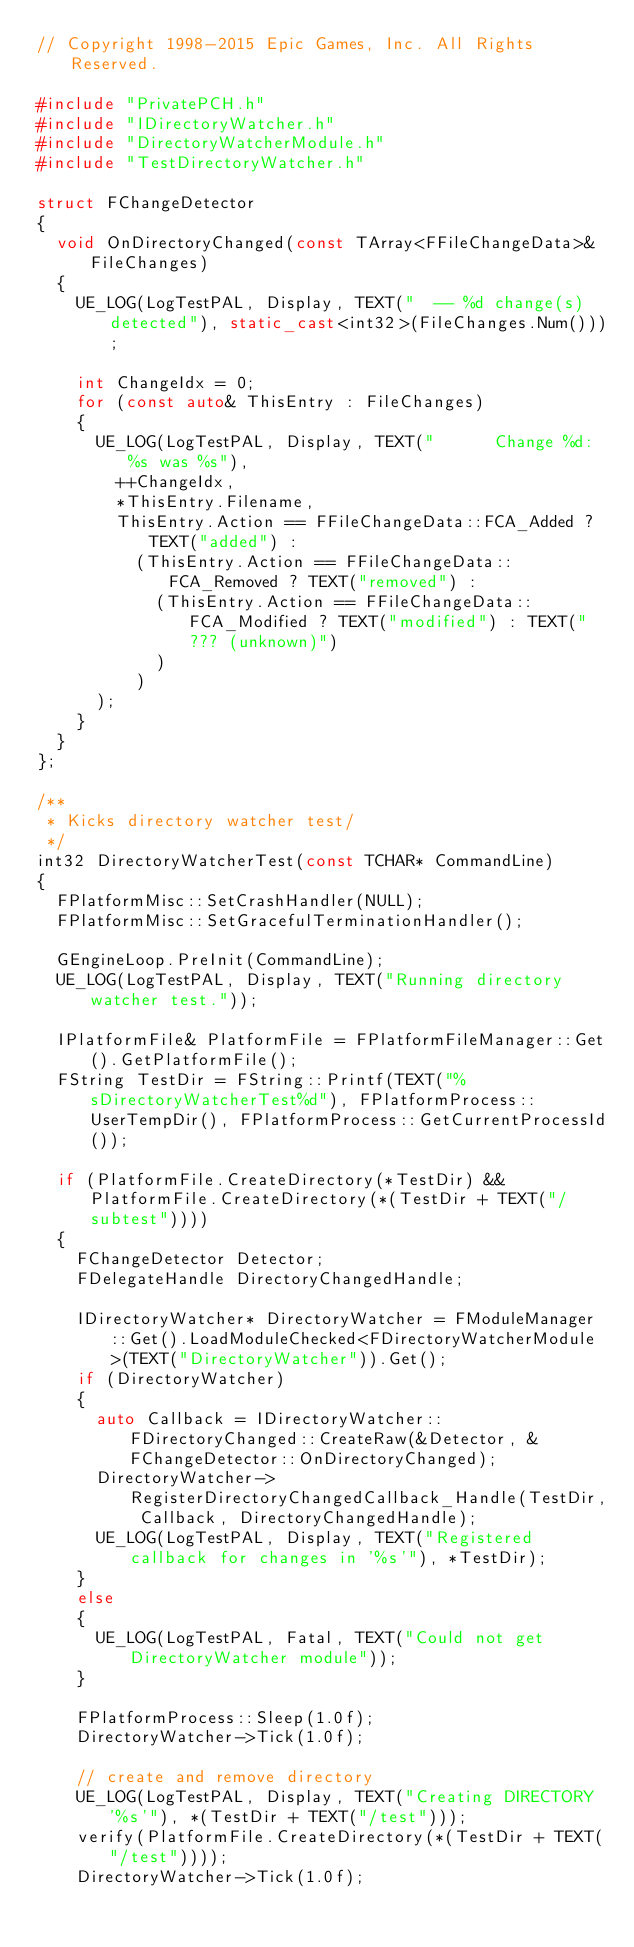Convert code to text. <code><loc_0><loc_0><loc_500><loc_500><_C++_>// Copyright 1998-2015 Epic Games, Inc. All Rights Reserved.

#include "PrivatePCH.h"
#include "IDirectoryWatcher.h"
#include "DirectoryWatcherModule.h"
#include "TestDirectoryWatcher.h"

struct FChangeDetector
{
	void OnDirectoryChanged(const TArray<FFileChangeData>& FileChanges)
	{
		UE_LOG(LogTestPAL, Display, TEXT("  -- %d change(s) detected"), static_cast<int32>(FileChanges.Num()));

		int ChangeIdx = 0;
		for (const auto& ThisEntry : FileChanges)
		{
			UE_LOG(LogTestPAL, Display, TEXT("      Change %d: %s was %s"),
				++ChangeIdx,
				*ThisEntry.Filename,
				ThisEntry.Action == FFileChangeData::FCA_Added ? TEXT("added") :
					(ThisEntry.Action == FFileChangeData::FCA_Removed ? TEXT("removed") :
						(ThisEntry.Action == FFileChangeData::FCA_Modified ? TEXT("modified") : TEXT("??? (unknown)")
						)
					)
			);
		}
	}
};

/**
 * Kicks directory watcher test/
 */
int32 DirectoryWatcherTest(const TCHAR* CommandLine)
{
	FPlatformMisc::SetCrashHandler(NULL);
	FPlatformMisc::SetGracefulTerminationHandler();

	GEngineLoop.PreInit(CommandLine);
	UE_LOG(LogTestPAL, Display, TEXT("Running directory watcher test."));

	IPlatformFile& PlatformFile = FPlatformFileManager::Get().GetPlatformFile();
	FString TestDir = FString::Printf(TEXT("%sDirectoryWatcherTest%d"), FPlatformProcess::UserTempDir(), FPlatformProcess::GetCurrentProcessId());

	if (PlatformFile.CreateDirectory(*TestDir) && PlatformFile.CreateDirectory(*(TestDir + TEXT("/subtest"))))
	{
		FChangeDetector Detector;
		FDelegateHandle DirectoryChangedHandle;

		IDirectoryWatcher* DirectoryWatcher = FModuleManager::Get().LoadModuleChecked<FDirectoryWatcherModule>(TEXT("DirectoryWatcher")).Get();
		if (DirectoryWatcher)
		{
			auto Callback = IDirectoryWatcher::FDirectoryChanged::CreateRaw(&Detector, &FChangeDetector::OnDirectoryChanged);
			DirectoryWatcher->RegisterDirectoryChangedCallback_Handle(TestDir, Callback, DirectoryChangedHandle);
			UE_LOG(LogTestPAL, Display, TEXT("Registered callback for changes in '%s'"), *TestDir);
		}
		else
		{
			UE_LOG(LogTestPAL, Fatal, TEXT("Could not get DirectoryWatcher module"));
		}

		FPlatformProcess::Sleep(1.0f);
		DirectoryWatcher->Tick(1.0f);

		// create and remove directory
		UE_LOG(LogTestPAL, Display, TEXT("Creating DIRECTORY '%s'"), *(TestDir + TEXT("/test")));
		verify(PlatformFile.CreateDirectory(*(TestDir + TEXT("/test"))));
		DirectoryWatcher->Tick(1.0f);</code> 